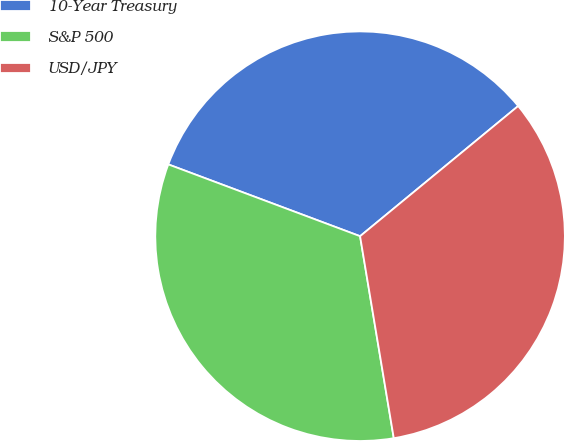Convert chart to OTSL. <chart><loc_0><loc_0><loc_500><loc_500><pie_chart><fcel>10-Year Treasury<fcel>S&P 500<fcel>USD/JPY<nl><fcel>33.33%<fcel>33.33%<fcel>33.33%<nl></chart> 